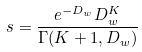Convert formula to latex. <formula><loc_0><loc_0><loc_500><loc_500>s = \frac { e ^ { - D _ { w } } D _ { w } ^ { K } } { \Gamma ( K + 1 , D _ { w } ) }</formula> 